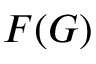Convert formula to latex. <formula><loc_0><loc_0><loc_500><loc_500>F ( G )</formula> 